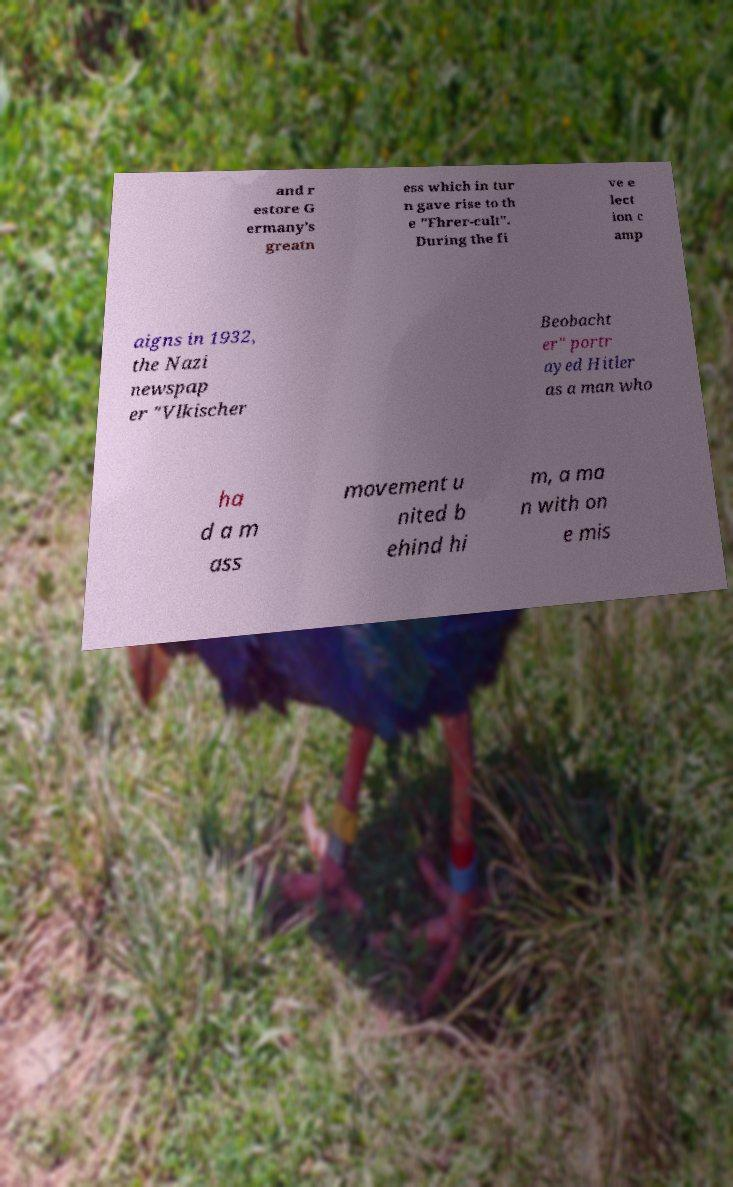There's text embedded in this image that I need extracted. Can you transcribe it verbatim? and r estore G ermany's greatn ess which in tur n gave rise to th e "Fhrer-cult". During the fi ve e lect ion c amp aigns in 1932, the Nazi newspap er "Vlkischer Beobacht er" portr ayed Hitler as a man who ha d a m ass movement u nited b ehind hi m, a ma n with on e mis 